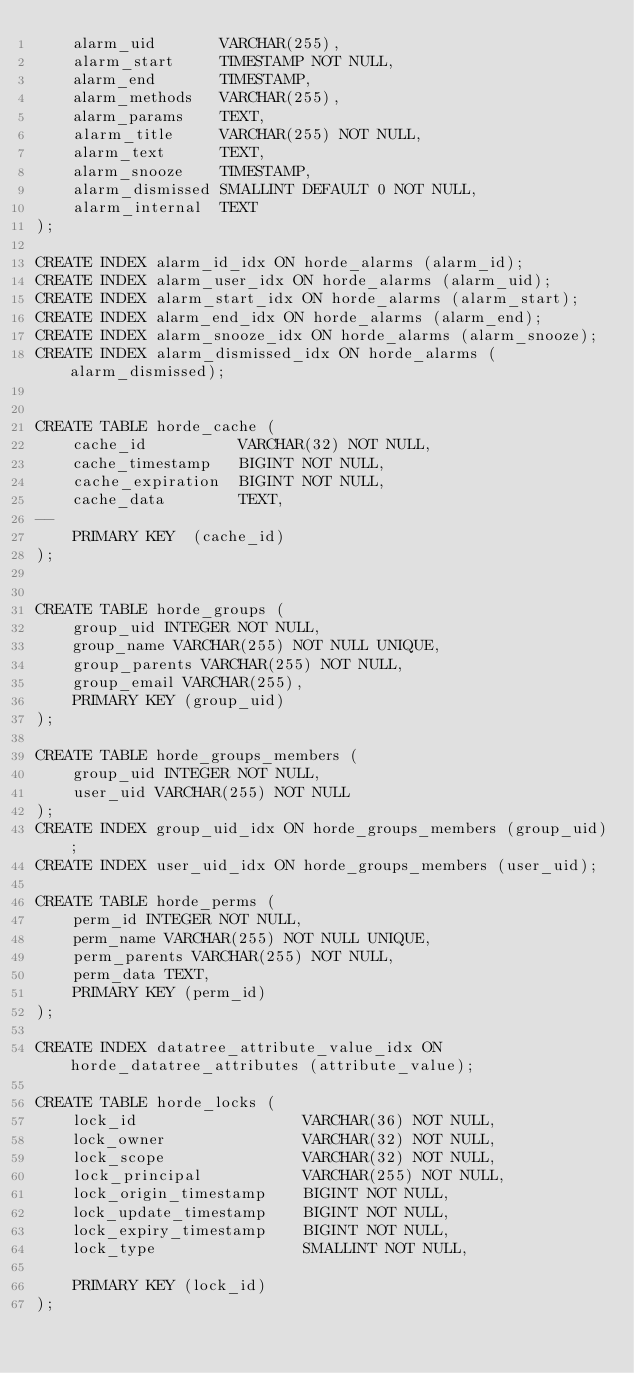<code> <loc_0><loc_0><loc_500><loc_500><_SQL_>    alarm_uid       VARCHAR(255),
    alarm_start     TIMESTAMP NOT NULL,
    alarm_end       TIMESTAMP,
    alarm_methods   VARCHAR(255),
    alarm_params    TEXT,
    alarm_title     VARCHAR(255) NOT NULL,
    alarm_text      TEXT,
    alarm_snooze    TIMESTAMP,
    alarm_dismissed SMALLINT DEFAULT 0 NOT NULL,
    alarm_internal  TEXT
);

CREATE INDEX alarm_id_idx ON horde_alarms (alarm_id);
CREATE INDEX alarm_user_idx ON horde_alarms (alarm_uid);
CREATE INDEX alarm_start_idx ON horde_alarms (alarm_start);
CREATE INDEX alarm_end_idx ON horde_alarms (alarm_end);
CREATE INDEX alarm_snooze_idx ON horde_alarms (alarm_snooze);
CREATE INDEX alarm_dismissed_idx ON horde_alarms (alarm_dismissed);


CREATE TABLE horde_cache (
    cache_id          VARCHAR(32) NOT NULL,
    cache_timestamp   BIGINT NOT NULL,
    cache_expiration  BIGINT NOT NULL,
    cache_data        TEXT,
--
    PRIMARY KEY  (cache_id)
);


CREATE TABLE horde_groups (
    group_uid INTEGER NOT NULL,
    group_name VARCHAR(255) NOT NULL UNIQUE,
    group_parents VARCHAR(255) NOT NULL,
    group_email VARCHAR(255),
    PRIMARY KEY (group_uid)
);

CREATE TABLE horde_groups_members (
    group_uid INTEGER NOT NULL,
    user_uid VARCHAR(255) NOT NULL
);
CREATE INDEX group_uid_idx ON horde_groups_members (group_uid);
CREATE INDEX user_uid_idx ON horde_groups_members (user_uid);

CREATE TABLE horde_perms (
    perm_id INTEGER NOT NULL,
    perm_name VARCHAR(255) NOT NULL UNIQUE,
    perm_parents VARCHAR(255) NOT NULL,
    perm_data TEXT,
    PRIMARY KEY (perm_id)
);

CREATE INDEX datatree_attribute_value_idx ON horde_datatree_attributes (attribute_value);

CREATE TABLE horde_locks (
    lock_id                  VARCHAR(36) NOT NULL,
    lock_owner               VARCHAR(32) NOT NULL,
    lock_scope               VARCHAR(32) NOT NULL,
    lock_principal           VARCHAR(255) NOT NULL,
    lock_origin_timestamp    BIGINT NOT NULL,
    lock_update_timestamp    BIGINT NOT NULL,
    lock_expiry_timestamp    BIGINT NOT NULL,
    lock_type                SMALLINT NOT NULL,

    PRIMARY KEY (lock_id)
);
</code> 